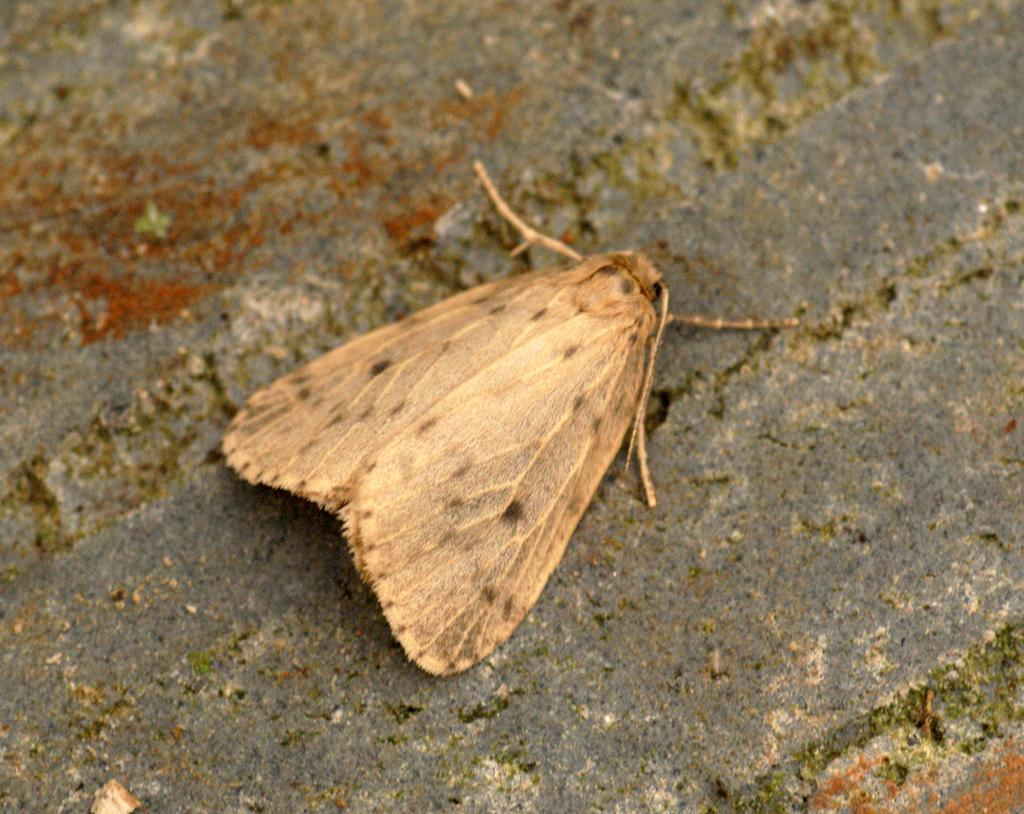What type of creature is present in the image? There is an insect in the image. Where is the insect located in the image? The insect is on the wall. What type of notebook is being compared to the insect in the image? There is no notebook present in the image, and no comparison is being made between the insect and any other object. 